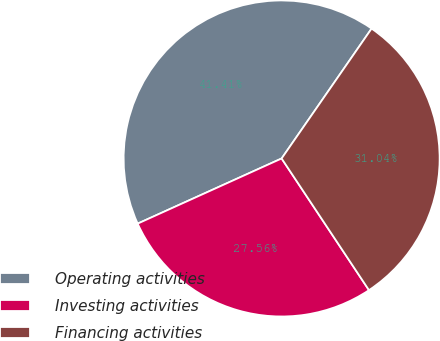<chart> <loc_0><loc_0><loc_500><loc_500><pie_chart><fcel>Operating activities<fcel>Investing activities<fcel>Financing activities<nl><fcel>41.41%<fcel>27.56%<fcel>31.04%<nl></chart> 